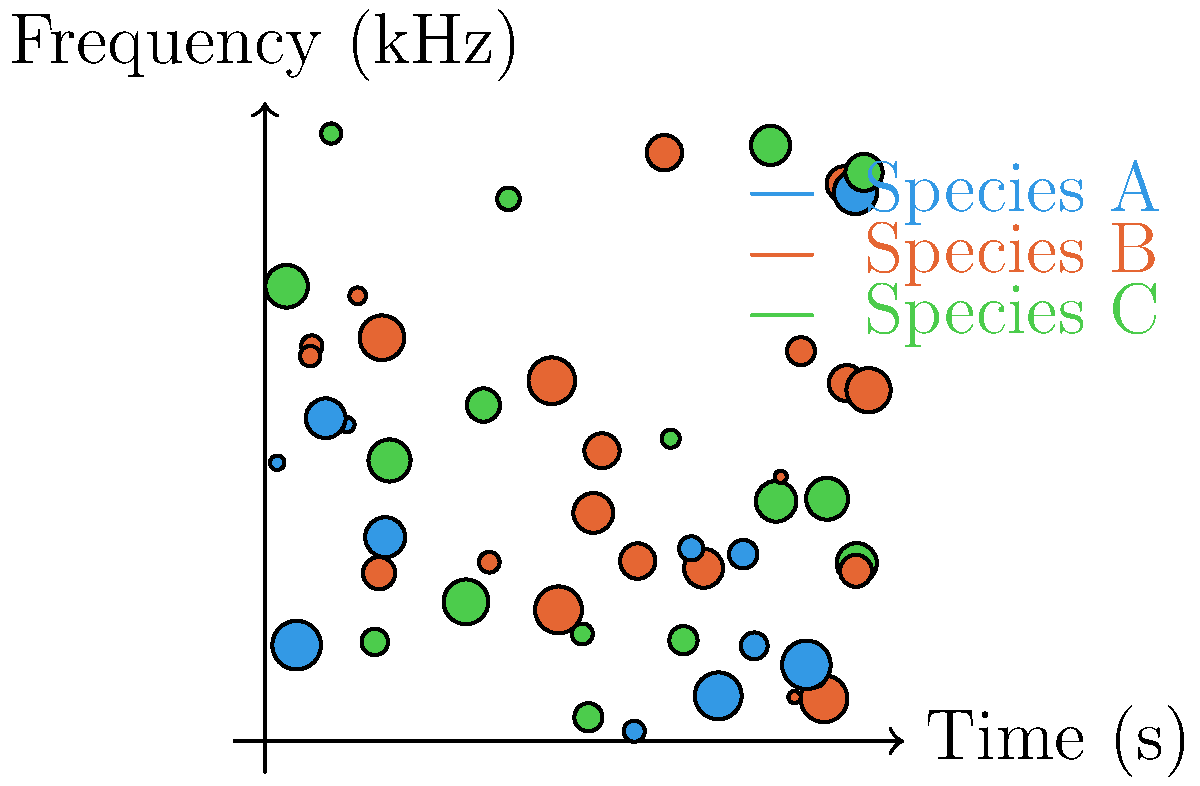In a machine learning project to identify and count bird species from audio recordings, you're presented with the spectrogram above. The x-axis represents time in seconds, and the y-axis represents frequency in kHz. Each colored dot represents a bird vocalization, with different colors corresponding to different species. If you were to design a convolutional neural network (CNN) to classify these species, what would be the minimum number of convolutional layers needed to effectively capture the spatial relationships between the vocalizations, assuming each layer reduces the spatial dimensions by half? To determine the minimum number of convolutional layers needed, we'll follow these steps:

1. Analyze the input dimensions:
   The spectrogram appears to be roughly 10x10 units (seconds x kHz).

2. Understand CNN architecture:
   Each convolutional layer typically reduces spatial dimensions by half when using a stride of 2 or max pooling.

3. Calculate the number of layers needed:
   We need to reduce the 10x10 input to 1x1 to capture global spatial relationships.
   
   Layer 1: 10x10 → 5x5
   Layer 2: 5x5 → 3x3 (rounded up)
   Layer 3: 3x3 → 2x2 (rounded up)
   Layer 4: 2x2 → 1x1

4. Consider the complexity of the patterns:
   The spectrogram shows distinct clusters and patterns for each species, which supports the need for multiple layers to capture these relationships effectively.

5. Account for potential overfitting:
   While 4 layers would reduce to 1x1, using 3 layers (reducing to 2x2) might be sufficient to capture the necessary spatial relationships without overfitting to noise in the data.

Therefore, the minimum number of convolutional layers needed is 3, which would reduce the spatial dimensions to 2x2, capturing most of the important spatial relationships between vocalizations while avoiding potential overfitting.
Answer: 3 convolutional layers 